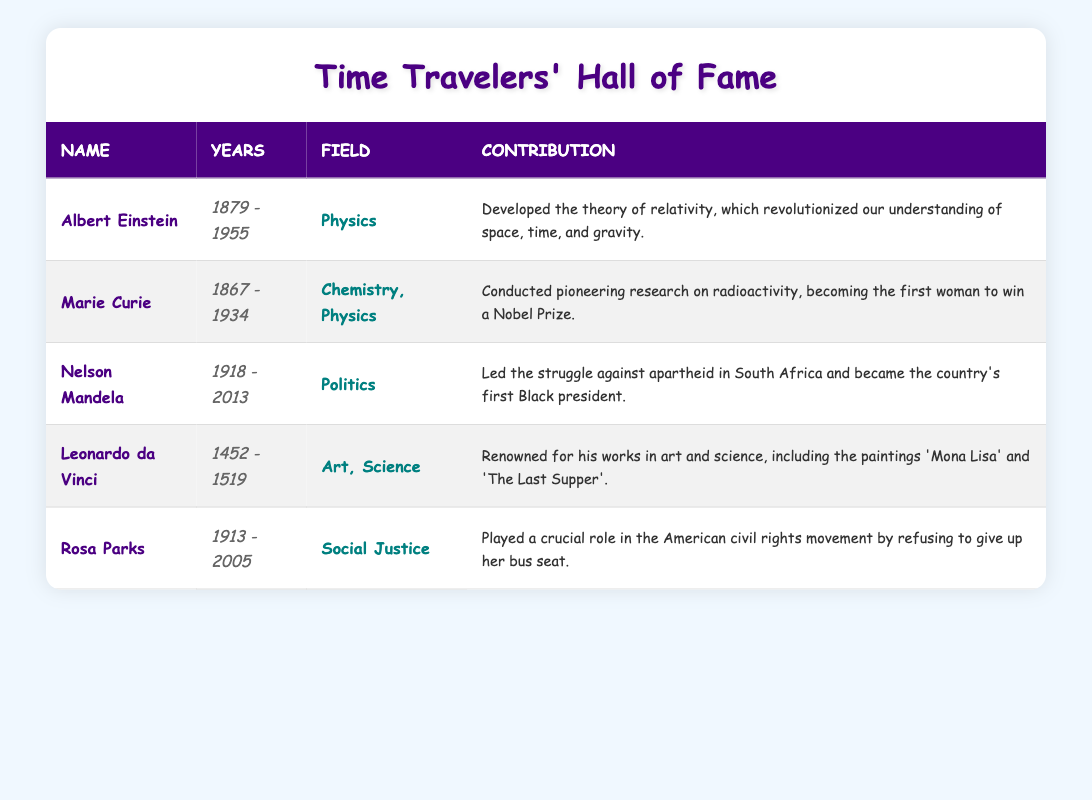What year was Albert Einstein born? By referencing the table, we find that Albert Einstein's birth year is listed as 1879.
Answer: 1879 Who conducted research on radioactivity? The table shows that Marie Curie conducted pioneering research on radioactivity.
Answer: Marie Curie Was Rosa Parks involved in politics? Based on the table, Rosa Parks is categorized under Social Justice, not Politics, so the answer is no.
Answer: No What is the average birth year of the historical figures listed? The birth years are 1879, 1867, 1918, 1452, and 1913. Adding these gives us 1879 + 1867 + 1918 + 1452 + 1913 = 10729. There are 5 figures, so the average birth year is 10729 / 5 = 2145.8. Since we cannot have a fraction of a year, the average is rounded to 2145.
Answer: 2145 Who is the only figure known for contributions in both art and science? The table indicates that Leonardo da Vinci is noted for his contributions in both Art and Science.
Answer: Leonardo da Vinci Did any of these historical figures live beyond the year 2000? Checking the death years, only Rosa Parks (2005) lived beyond the year 2000.
Answer: Yes What is the combined lifespan (years alive) of Marie Curie and Rosa Parks? Marie Curie was born in 1867 and died in 1934, so her lifespan was 1934 - 1867 = 67 years. Rosa Parks was born in 1913 and died in 2005, so her lifespan was 2005 - 1913 = 92 years. Combining both gives us 67 + 92 = 159 years.
Answer: 159 Which figure is known for leading the struggle against apartheid? According to the table, Nelson Mandela is recognized for leading the struggle against apartheid in South Africa.
Answer: Nelson Mandela How many figures contributed to both chemistry and physics? The table specifies that only Marie Curie contributed to both chemistry and physics.
Answer: 1 